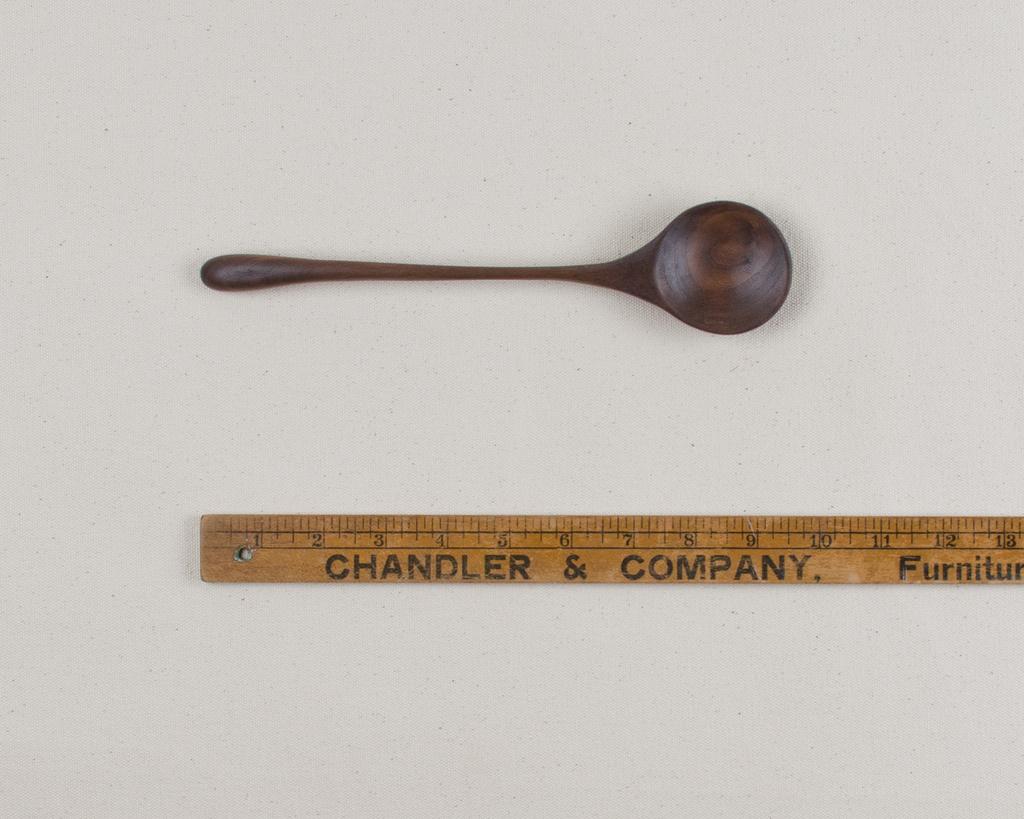How long is the wooden spoon?
Keep it short and to the point. 10 inches. 